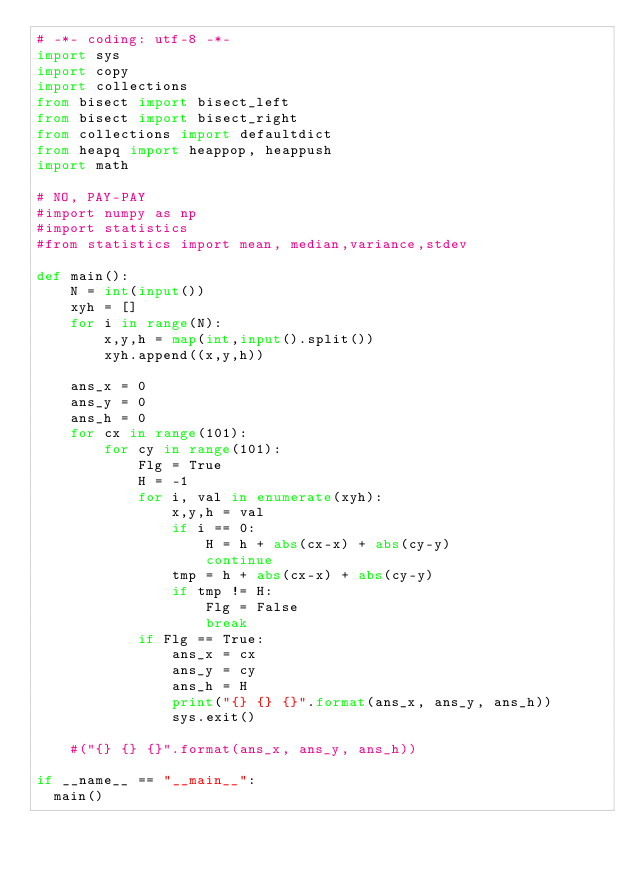<code> <loc_0><loc_0><loc_500><loc_500><_Python_># -*- coding: utf-8 -*-
import sys
import copy
import collections
from bisect import bisect_left
from bisect import bisect_right
from collections import defaultdict
from heapq import heappop, heappush
import math

# NO, PAY-PAY
#import numpy as np
#import statistics
#from statistics import mean, median,variance,stdev
 
def main():
    N = int(input())
    xyh = []
    for i in range(N):
        x,y,h = map(int,input().split())
        xyh.append((x,y,h))
        
    ans_x = 0
    ans_y = 0
    ans_h = 0
    for cx in range(101):
        for cy in range(101):
            Flg = True
            H = -1
            for i, val in enumerate(xyh):
                x,y,h = val
                if i == 0:
                    H = h + abs(cx-x) + abs(cy-y)
                    continue
                tmp = h + abs(cx-x) + abs(cy-y)
                if tmp != H:
                    Flg = False
                    break
            if Flg == True:
                ans_x = cx
                ans_y = cy
                ans_h = H
                print("{} {} {}".format(ans_x, ans_y, ans_h))
                sys.exit()
            
    #("{} {} {}".format(ans_x, ans_y, ans_h))
	
if __name__ == "__main__":
	main()
</code> 